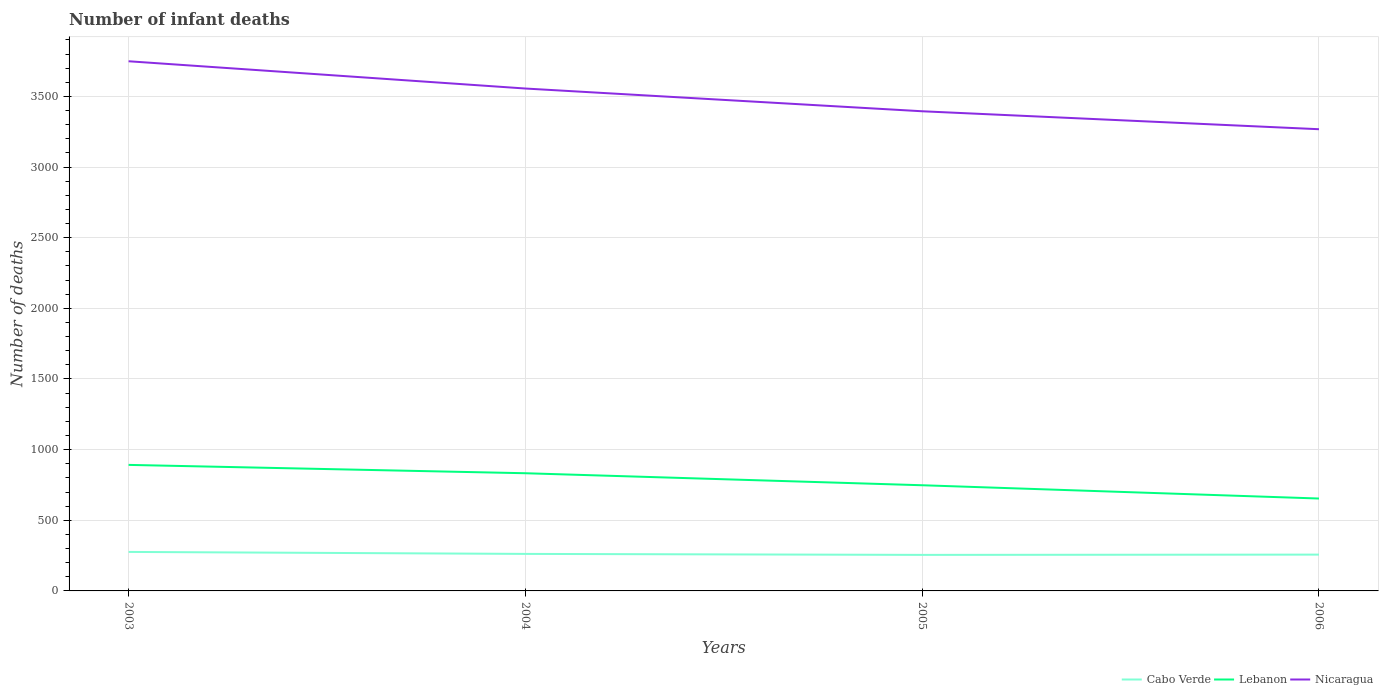Does the line corresponding to Cabo Verde intersect with the line corresponding to Nicaragua?
Give a very brief answer. No. Is the number of lines equal to the number of legend labels?
Your answer should be very brief. Yes. Across all years, what is the maximum number of infant deaths in Nicaragua?
Your response must be concise. 3268. What is the total number of infant deaths in Nicaragua in the graph?
Make the answer very short. 288. What is the difference between the highest and the second highest number of infant deaths in Cabo Verde?
Your response must be concise. 21. What is the difference between the highest and the lowest number of infant deaths in Cabo Verde?
Offer a very short reply. 1. Is the number of infant deaths in Lebanon strictly greater than the number of infant deaths in Nicaragua over the years?
Give a very brief answer. Yes. How many lines are there?
Give a very brief answer. 3. How many years are there in the graph?
Give a very brief answer. 4. What is the difference between two consecutive major ticks on the Y-axis?
Provide a succinct answer. 500. Does the graph contain grids?
Provide a succinct answer. Yes. Where does the legend appear in the graph?
Provide a succinct answer. Bottom right. How many legend labels are there?
Offer a terse response. 3. What is the title of the graph?
Provide a short and direct response. Number of infant deaths. What is the label or title of the X-axis?
Your response must be concise. Years. What is the label or title of the Y-axis?
Give a very brief answer. Number of deaths. What is the Number of deaths in Cabo Verde in 2003?
Provide a succinct answer. 276. What is the Number of deaths in Lebanon in 2003?
Offer a terse response. 892. What is the Number of deaths in Nicaragua in 2003?
Offer a terse response. 3749. What is the Number of deaths of Cabo Verde in 2004?
Give a very brief answer. 262. What is the Number of deaths in Lebanon in 2004?
Your response must be concise. 833. What is the Number of deaths in Nicaragua in 2004?
Your answer should be compact. 3556. What is the Number of deaths of Cabo Verde in 2005?
Keep it short and to the point. 255. What is the Number of deaths of Lebanon in 2005?
Make the answer very short. 748. What is the Number of deaths in Nicaragua in 2005?
Your answer should be very brief. 3395. What is the Number of deaths in Cabo Verde in 2006?
Provide a short and direct response. 257. What is the Number of deaths in Lebanon in 2006?
Keep it short and to the point. 654. What is the Number of deaths of Nicaragua in 2006?
Your answer should be very brief. 3268. Across all years, what is the maximum Number of deaths in Cabo Verde?
Your response must be concise. 276. Across all years, what is the maximum Number of deaths in Lebanon?
Keep it short and to the point. 892. Across all years, what is the maximum Number of deaths in Nicaragua?
Offer a terse response. 3749. Across all years, what is the minimum Number of deaths of Cabo Verde?
Ensure brevity in your answer.  255. Across all years, what is the minimum Number of deaths in Lebanon?
Keep it short and to the point. 654. Across all years, what is the minimum Number of deaths in Nicaragua?
Offer a terse response. 3268. What is the total Number of deaths of Cabo Verde in the graph?
Offer a very short reply. 1050. What is the total Number of deaths of Lebanon in the graph?
Make the answer very short. 3127. What is the total Number of deaths of Nicaragua in the graph?
Ensure brevity in your answer.  1.40e+04. What is the difference between the Number of deaths of Cabo Verde in 2003 and that in 2004?
Ensure brevity in your answer.  14. What is the difference between the Number of deaths of Lebanon in 2003 and that in 2004?
Make the answer very short. 59. What is the difference between the Number of deaths of Nicaragua in 2003 and that in 2004?
Give a very brief answer. 193. What is the difference between the Number of deaths of Lebanon in 2003 and that in 2005?
Provide a succinct answer. 144. What is the difference between the Number of deaths in Nicaragua in 2003 and that in 2005?
Your response must be concise. 354. What is the difference between the Number of deaths of Cabo Verde in 2003 and that in 2006?
Your answer should be compact. 19. What is the difference between the Number of deaths of Lebanon in 2003 and that in 2006?
Offer a very short reply. 238. What is the difference between the Number of deaths of Nicaragua in 2003 and that in 2006?
Ensure brevity in your answer.  481. What is the difference between the Number of deaths in Cabo Verde in 2004 and that in 2005?
Keep it short and to the point. 7. What is the difference between the Number of deaths in Nicaragua in 2004 and that in 2005?
Your answer should be very brief. 161. What is the difference between the Number of deaths in Cabo Verde in 2004 and that in 2006?
Keep it short and to the point. 5. What is the difference between the Number of deaths in Lebanon in 2004 and that in 2006?
Keep it short and to the point. 179. What is the difference between the Number of deaths in Nicaragua in 2004 and that in 2006?
Provide a succinct answer. 288. What is the difference between the Number of deaths in Cabo Verde in 2005 and that in 2006?
Your response must be concise. -2. What is the difference between the Number of deaths in Lebanon in 2005 and that in 2006?
Offer a very short reply. 94. What is the difference between the Number of deaths in Nicaragua in 2005 and that in 2006?
Provide a short and direct response. 127. What is the difference between the Number of deaths of Cabo Verde in 2003 and the Number of deaths of Lebanon in 2004?
Your response must be concise. -557. What is the difference between the Number of deaths of Cabo Verde in 2003 and the Number of deaths of Nicaragua in 2004?
Your answer should be compact. -3280. What is the difference between the Number of deaths of Lebanon in 2003 and the Number of deaths of Nicaragua in 2004?
Offer a very short reply. -2664. What is the difference between the Number of deaths in Cabo Verde in 2003 and the Number of deaths in Lebanon in 2005?
Provide a short and direct response. -472. What is the difference between the Number of deaths of Cabo Verde in 2003 and the Number of deaths of Nicaragua in 2005?
Your answer should be very brief. -3119. What is the difference between the Number of deaths in Lebanon in 2003 and the Number of deaths in Nicaragua in 2005?
Keep it short and to the point. -2503. What is the difference between the Number of deaths in Cabo Verde in 2003 and the Number of deaths in Lebanon in 2006?
Your answer should be very brief. -378. What is the difference between the Number of deaths of Cabo Verde in 2003 and the Number of deaths of Nicaragua in 2006?
Make the answer very short. -2992. What is the difference between the Number of deaths of Lebanon in 2003 and the Number of deaths of Nicaragua in 2006?
Your answer should be compact. -2376. What is the difference between the Number of deaths of Cabo Verde in 2004 and the Number of deaths of Lebanon in 2005?
Offer a terse response. -486. What is the difference between the Number of deaths of Cabo Verde in 2004 and the Number of deaths of Nicaragua in 2005?
Offer a very short reply. -3133. What is the difference between the Number of deaths in Lebanon in 2004 and the Number of deaths in Nicaragua in 2005?
Your answer should be very brief. -2562. What is the difference between the Number of deaths in Cabo Verde in 2004 and the Number of deaths in Lebanon in 2006?
Offer a very short reply. -392. What is the difference between the Number of deaths in Cabo Verde in 2004 and the Number of deaths in Nicaragua in 2006?
Provide a short and direct response. -3006. What is the difference between the Number of deaths in Lebanon in 2004 and the Number of deaths in Nicaragua in 2006?
Your answer should be compact. -2435. What is the difference between the Number of deaths of Cabo Verde in 2005 and the Number of deaths of Lebanon in 2006?
Provide a succinct answer. -399. What is the difference between the Number of deaths in Cabo Verde in 2005 and the Number of deaths in Nicaragua in 2006?
Your response must be concise. -3013. What is the difference between the Number of deaths in Lebanon in 2005 and the Number of deaths in Nicaragua in 2006?
Your answer should be very brief. -2520. What is the average Number of deaths in Cabo Verde per year?
Provide a succinct answer. 262.5. What is the average Number of deaths of Lebanon per year?
Make the answer very short. 781.75. What is the average Number of deaths in Nicaragua per year?
Offer a very short reply. 3492. In the year 2003, what is the difference between the Number of deaths of Cabo Verde and Number of deaths of Lebanon?
Offer a terse response. -616. In the year 2003, what is the difference between the Number of deaths of Cabo Verde and Number of deaths of Nicaragua?
Make the answer very short. -3473. In the year 2003, what is the difference between the Number of deaths in Lebanon and Number of deaths in Nicaragua?
Your answer should be compact. -2857. In the year 2004, what is the difference between the Number of deaths in Cabo Verde and Number of deaths in Lebanon?
Provide a succinct answer. -571. In the year 2004, what is the difference between the Number of deaths of Cabo Verde and Number of deaths of Nicaragua?
Provide a short and direct response. -3294. In the year 2004, what is the difference between the Number of deaths of Lebanon and Number of deaths of Nicaragua?
Offer a very short reply. -2723. In the year 2005, what is the difference between the Number of deaths of Cabo Verde and Number of deaths of Lebanon?
Your answer should be very brief. -493. In the year 2005, what is the difference between the Number of deaths of Cabo Verde and Number of deaths of Nicaragua?
Keep it short and to the point. -3140. In the year 2005, what is the difference between the Number of deaths in Lebanon and Number of deaths in Nicaragua?
Your response must be concise. -2647. In the year 2006, what is the difference between the Number of deaths in Cabo Verde and Number of deaths in Lebanon?
Ensure brevity in your answer.  -397. In the year 2006, what is the difference between the Number of deaths of Cabo Verde and Number of deaths of Nicaragua?
Ensure brevity in your answer.  -3011. In the year 2006, what is the difference between the Number of deaths of Lebanon and Number of deaths of Nicaragua?
Your answer should be compact. -2614. What is the ratio of the Number of deaths in Cabo Verde in 2003 to that in 2004?
Keep it short and to the point. 1.05. What is the ratio of the Number of deaths of Lebanon in 2003 to that in 2004?
Offer a very short reply. 1.07. What is the ratio of the Number of deaths of Nicaragua in 2003 to that in 2004?
Ensure brevity in your answer.  1.05. What is the ratio of the Number of deaths of Cabo Verde in 2003 to that in 2005?
Offer a very short reply. 1.08. What is the ratio of the Number of deaths of Lebanon in 2003 to that in 2005?
Provide a short and direct response. 1.19. What is the ratio of the Number of deaths in Nicaragua in 2003 to that in 2005?
Make the answer very short. 1.1. What is the ratio of the Number of deaths in Cabo Verde in 2003 to that in 2006?
Offer a very short reply. 1.07. What is the ratio of the Number of deaths in Lebanon in 2003 to that in 2006?
Provide a short and direct response. 1.36. What is the ratio of the Number of deaths in Nicaragua in 2003 to that in 2006?
Offer a terse response. 1.15. What is the ratio of the Number of deaths in Cabo Verde in 2004 to that in 2005?
Your response must be concise. 1.03. What is the ratio of the Number of deaths in Lebanon in 2004 to that in 2005?
Give a very brief answer. 1.11. What is the ratio of the Number of deaths in Nicaragua in 2004 to that in 2005?
Provide a short and direct response. 1.05. What is the ratio of the Number of deaths in Cabo Verde in 2004 to that in 2006?
Your response must be concise. 1.02. What is the ratio of the Number of deaths in Lebanon in 2004 to that in 2006?
Provide a succinct answer. 1.27. What is the ratio of the Number of deaths of Nicaragua in 2004 to that in 2006?
Your response must be concise. 1.09. What is the ratio of the Number of deaths in Cabo Verde in 2005 to that in 2006?
Provide a succinct answer. 0.99. What is the ratio of the Number of deaths in Lebanon in 2005 to that in 2006?
Provide a short and direct response. 1.14. What is the ratio of the Number of deaths in Nicaragua in 2005 to that in 2006?
Make the answer very short. 1.04. What is the difference between the highest and the second highest Number of deaths in Cabo Verde?
Offer a terse response. 14. What is the difference between the highest and the second highest Number of deaths in Nicaragua?
Provide a short and direct response. 193. What is the difference between the highest and the lowest Number of deaths of Cabo Verde?
Provide a succinct answer. 21. What is the difference between the highest and the lowest Number of deaths of Lebanon?
Your response must be concise. 238. What is the difference between the highest and the lowest Number of deaths of Nicaragua?
Offer a terse response. 481. 